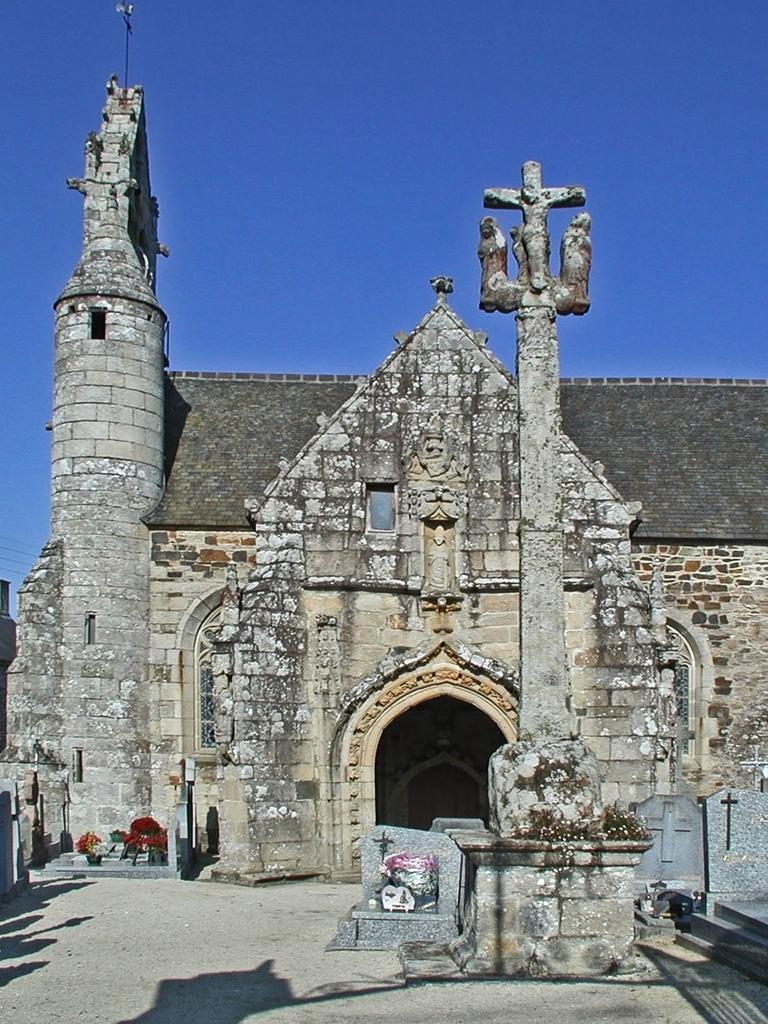What type of structures can be seen in the image? A: There are buildings in the image. What other objects are present in the image? There are houseplants and stairs visible in the image. What can be seen in the background of the image? The sky is visible in the background of the image. How many patches are on the hands of the person in the image? There is no person present in the image, and therefore no hands or patches can be observed. What type of card is being used to prop open the door in the image? There is no door or card present in the image. 